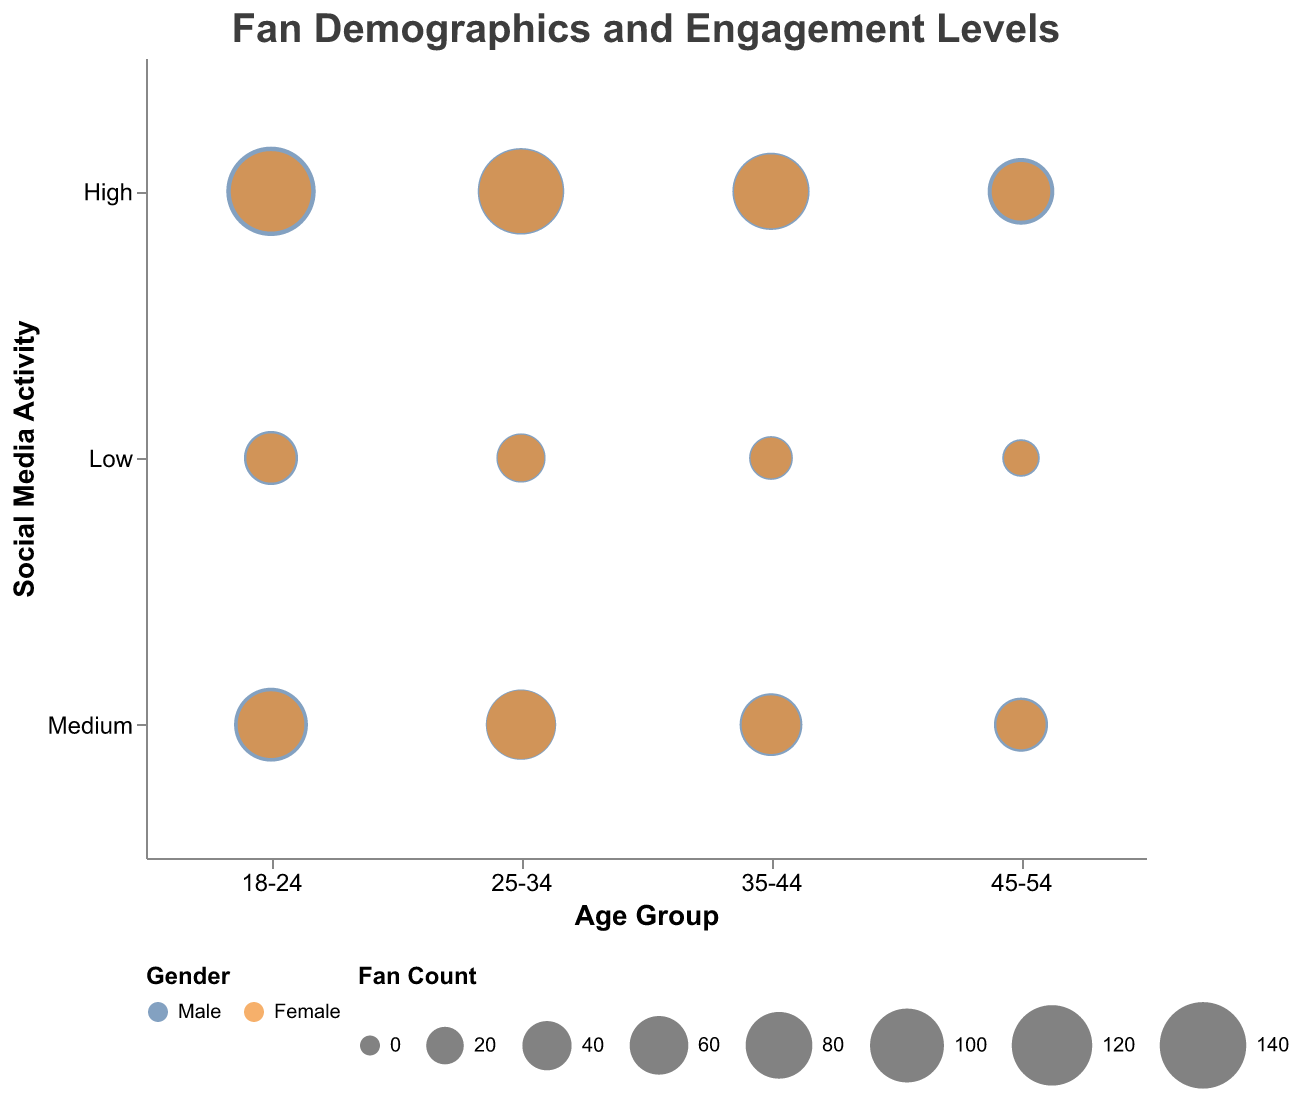What's the title of the chart? The title is displayed prominently at the top of the chart. It reads, "Fan Demographics and Engagement Levels."
Answer: Fan Demographics and Engagement Levels Which age group has the highest fan count for males with high social media activity? Refer to the bubbles corresponding to males with high social media activity in each age group. The largest bubble indicates the highest fan count. For males with high social media activity, the age group 18-24 has the largest bubble.
Answer: 18-24 How many age groups are represented on the x-axis? The x-axis lists distinct age groups. Counting them will provide the answer. The age groups are: 18-24, 25-34, 35-44, and 45-54.
Answer: 4 Which gender has higher fan engagement (high social media activity) in the 25-34 age group? Compare the sizes of bubbles for high social media activity within the 25-34 age group. The bubble for females is larger than that for males.
Answer: Female What is the combined fan count for the age group 35-44 with high social media activity? Count the fan numbers for both genders in the 35-44 age group with high social media activity. The bubble for males is 110 and for females is 100. So, 110 + 100 = 210.
Answer: 210 Which gender has more fans with medium social media activity in the 45-54 age group? Compare the bubble sizes for males and females with medium social media activity in the 45-54 age group. The bubble for males has a fan count of 50, while females have a fan count of 40.
Answer: Male How does fan engagement differ between males and females aged 18-24 with low social media activity? Compare the sizes of the bubbles for males and females aged 18-24 with low social media activity. For males, the fan count is 50, and for females, it is 40. So males have a higher count by 10 fans.
Answer: Males have 10 more fans than females What is the average fan count for all female fans with low social media activity? Calculate the fan counts for females with low social media activity in all age groups: 40 (18-24) + 35 (25-34) + 25 (35-44) + 15 (45-54) = 115. There are four age groups, so the average is 115 / 4 = 28.75.
Answer: 28.75 In the age group 25-34, which level of social media activity has the lowest total fan count, and what is it? Check the bubble sizes for each level of social media activity for the 25-34 age group for both males and females. Adding the values: High = 140 + 130 = 270, Medium = 90 + 85 = 175, Low = 40 + 35 = 75. Low social media activity has the lowest total fan count, which is 75.
Answer: Low, 75 